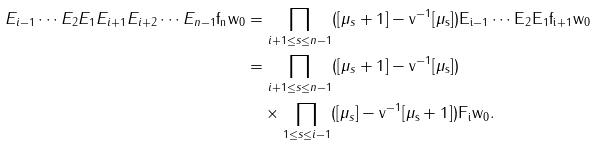<formula> <loc_0><loc_0><loc_500><loc_500>E _ { i - 1 } \cdots E _ { 2 } E _ { 1 } E _ { i + 1 } E _ { i + 2 } \cdots E _ { n - 1 } \tt f _ { n } w _ { 0 } & = \prod _ { i + 1 \leq s \leq n - 1 } ( [ \mu _ { s } + 1 ] - \tt v ^ { - 1 } [ \mu _ { s } ] ) E _ { i - 1 } \cdots E _ { 2 } E _ { 1 } \tt f _ { i + 1 } w _ { 0 } \\ & = \prod _ { i + 1 \leq s \leq n - 1 } ( [ \mu _ { s } + 1 ] - \tt v ^ { - 1 } [ \mu _ { s } ] ) \\ & \quad \times \prod _ { 1 \leq s \leq i - 1 } ( [ \mu _ { s } ] - \tt v ^ { - 1 } [ \mu _ { s } + 1 ] ) F _ { i } w _ { 0 } .</formula> 